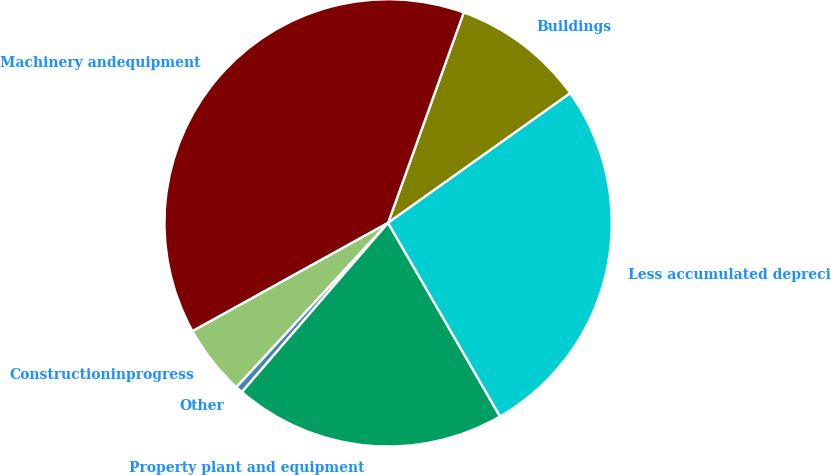<chart> <loc_0><loc_0><loc_500><loc_500><pie_chart><fcel>Buildings<fcel>Machinery andequipment<fcel>Constructioninprogress<fcel>Other<fcel>Property plant and equipment<fcel>Less accumulated depreciation<nl><fcel>9.66%<fcel>38.54%<fcel>5.09%<fcel>0.52%<fcel>19.69%<fcel>26.5%<nl></chart> 